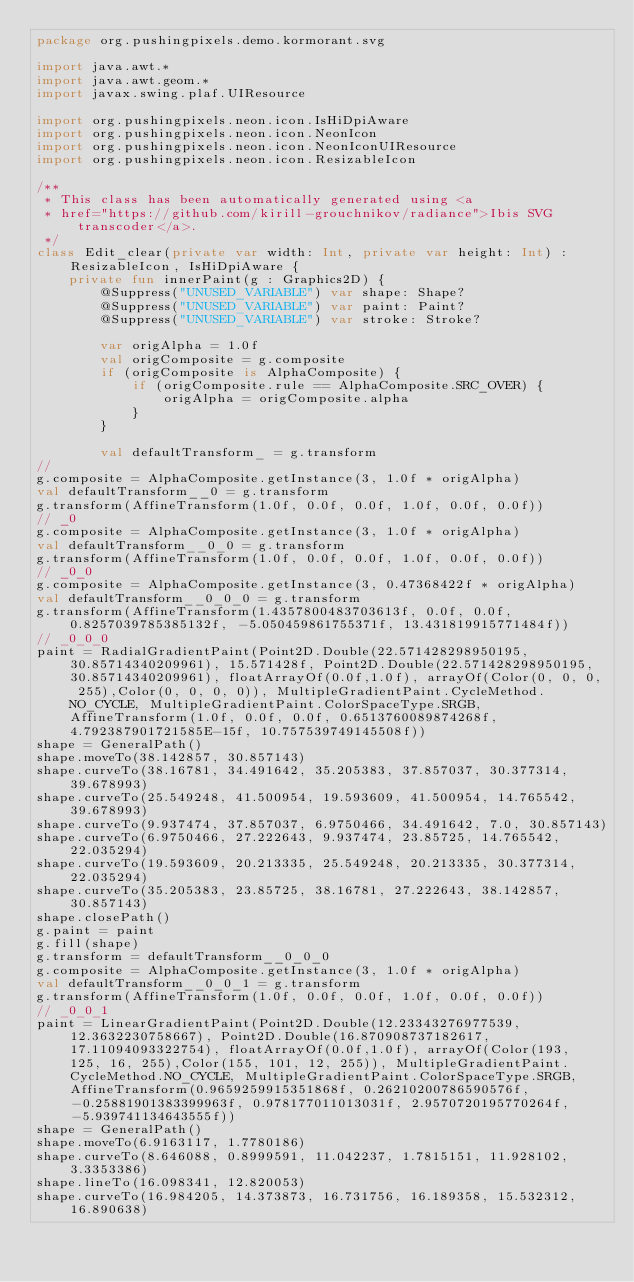Convert code to text. <code><loc_0><loc_0><loc_500><loc_500><_Kotlin_>package org.pushingpixels.demo.kormorant.svg

import java.awt.*
import java.awt.geom.*
import javax.swing.plaf.UIResource

import org.pushingpixels.neon.icon.IsHiDpiAware
import org.pushingpixels.neon.icon.NeonIcon
import org.pushingpixels.neon.icon.NeonIconUIResource
import org.pushingpixels.neon.icon.ResizableIcon

/**
 * This class has been automatically generated using <a
 * href="https://github.com/kirill-grouchnikov/radiance">Ibis SVG transcoder</a>.
 */
class Edit_clear(private var width: Int, private var height: Int) : ResizableIcon, IsHiDpiAware {
	private fun innerPaint(g : Graphics2D) {
        @Suppress("UNUSED_VARIABLE") var shape: Shape?
        @Suppress("UNUSED_VARIABLE") var paint: Paint?
        @Suppress("UNUSED_VARIABLE") var stroke: Stroke?
         
        var origAlpha = 1.0f
        val origComposite = g.composite
        if (origComposite is AlphaComposite) {
            if (origComposite.rule == AlphaComposite.SRC_OVER) {
                origAlpha = origComposite.alpha
            }
        }
        
	    val defaultTransform_ = g.transform
// 
g.composite = AlphaComposite.getInstance(3, 1.0f * origAlpha)
val defaultTransform__0 = g.transform
g.transform(AffineTransform(1.0f, 0.0f, 0.0f, 1.0f, 0.0f, 0.0f))
// _0
g.composite = AlphaComposite.getInstance(3, 1.0f * origAlpha)
val defaultTransform__0_0 = g.transform
g.transform(AffineTransform(1.0f, 0.0f, 0.0f, 1.0f, 0.0f, 0.0f))
// _0_0
g.composite = AlphaComposite.getInstance(3, 0.47368422f * origAlpha)
val defaultTransform__0_0_0 = g.transform
g.transform(AffineTransform(1.4357800483703613f, 0.0f, 0.0f, 0.8257039785385132f, -5.050459861755371f, 13.431819915771484f))
// _0_0_0
paint = RadialGradientPaint(Point2D.Double(22.571428298950195, 30.85714340209961), 15.571428f, Point2D.Double(22.571428298950195, 30.85714340209961), floatArrayOf(0.0f,1.0f), arrayOf(Color(0, 0, 0, 255),Color(0, 0, 0, 0)), MultipleGradientPaint.CycleMethod.NO_CYCLE, MultipleGradientPaint.ColorSpaceType.SRGB, AffineTransform(1.0f, 0.0f, 0.0f, 0.6513760089874268f, 4.792387901721585E-15f, 10.757539749145508f))
shape = GeneralPath()
shape.moveTo(38.142857, 30.857143)
shape.curveTo(38.16781, 34.491642, 35.205383, 37.857037, 30.377314, 39.678993)
shape.curveTo(25.549248, 41.500954, 19.593609, 41.500954, 14.765542, 39.678993)
shape.curveTo(9.937474, 37.857037, 6.9750466, 34.491642, 7.0, 30.857143)
shape.curveTo(6.9750466, 27.222643, 9.937474, 23.85725, 14.765542, 22.035294)
shape.curveTo(19.593609, 20.213335, 25.549248, 20.213335, 30.377314, 22.035294)
shape.curveTo(35.205383, 23.85725, 38.16781, 27.222643, 38.142857, 30.857143)
shape.closePath()
g.paint = paint
g.fill(shape)
g.transform = defaultTransform__0_0_0
g.composite = AlphaComposite.getInstance(3, 1.0f * origAlpha)
val defaultTransform__0_0_1 = g.transform
g.transform(AffineTransform(1.0f, 0.0f, 0.0f, 1.0f, 0.0f, 0.0f))
// _0_0_1
paint = LinearGradientPaint(Point2D.Double(12.23343276977539, 12.3632230758667), Point2D.Double(16.870908737182617, 17.11094093322754), floatArrayOf(0.0f,1.0f), arrayOf(Color(193, 125, 16, 255),Color(155, 101, 12, 255)), MultipleGradientPaint.CycleMethod.NO_CYCLE, MultipleGradientPaint.ColorSpaceType.SRGB, AffineTransform(0.9659259915351868f, 0.26210200786590576f, -0.25881901383399963f, 0.978177011013031f, 2.9570720195770264f, -5.939741134643555f))
shape = GeneralPath()
shape.moveTo(6.9163117, 1.7780186)
shape.curveTo(8.646088, 0.8999591, 11.042237, 1.7815151, 11.928102, 3.3353386)
shape.lineTo(16.098341, 12.820053)
shape.curveTo(16.984205, 14.373873, 16.731756, 16.189358, 15.532312, 16.890638)</code> 